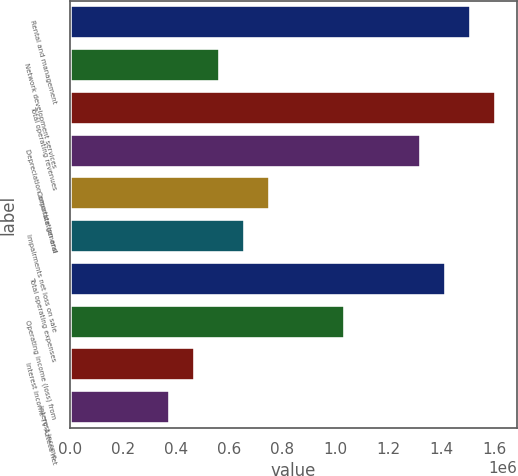Convert chart. <chart><loc_0><loc_0><loc_500><loc_500><bar_chart><fcel>Rental and management<fcel>Network development services<fcel>Total operating revenues<fcel>Depreciation amortization and<fcel>Corporate general<fcel>Impairments net loss on sale<fcel>Total operating expenses<fcel>Operating income (loss) from<fcel>Interest income TV Azteca net<fcel>Interest income<nl><fcel>1.51166e+06<fcel>566872<fcel>1.60614e+06<fcel>1.3227e+06<fcel>755829<fcel>661350<fcel>1.41718e+06<fcel>1.03926e+06<fcel>472393<fcel>377915<nl></chart> 